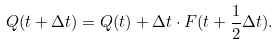Convert formula to latex. <formula><loc_0><loc_0><loc_500><loc_500>Q ( t + \Delta t ) = Q ( t ) + \Delta t \cdot F ( t + \frac { 1 } { 2 } \Delta t ) .</formula> 